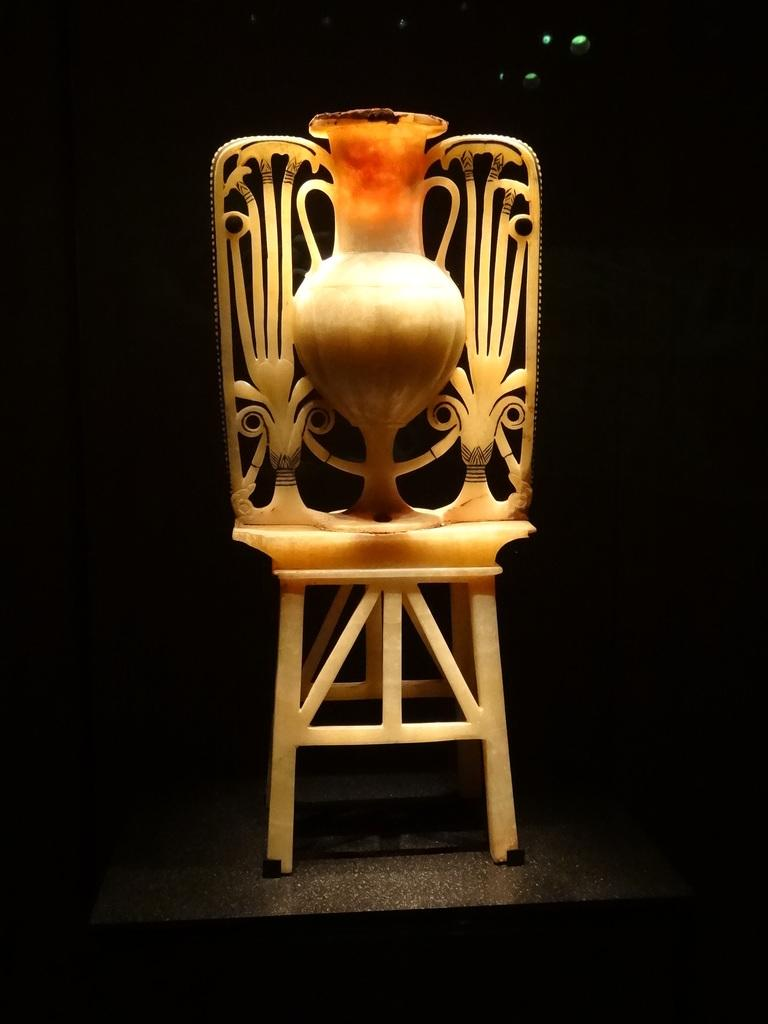What object can be seen in the image? There is a flower vase in the image. Where is the flower vase located? The flower vase is placed on a table. What type of toothbrush is used to water the grass in the image? There is no toothbrush or grass present in the image; it only features a flower vase placed on a table. 